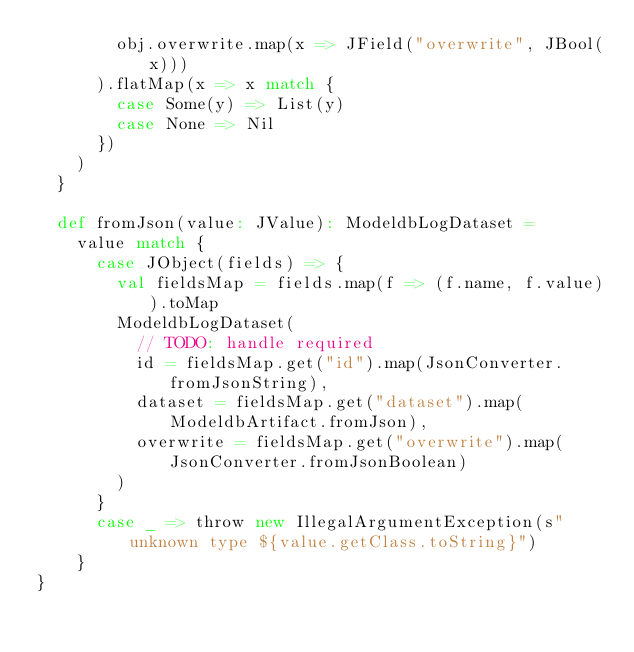Convert code to text. <code><loc_0><loc_0><loc_500><loc_500><_Scala_>        obj.overwrite.map(x => JField("overwrite", JBool(x)))
      ).flatMap(x => x match {
        case Some(y) => List(y)
        case None => Nil
      })
    )
  }

  def fromJson(value: JValue): ModeldbLogDataset =
    value match {
      case JObject(fields) => {
        val fieldsMap = fields.map(f => (f.name, f.value)).toMap
        ModeldbLogDataset(
          // TODO: handle required
          id = fieldsMap.get("id").map(JsonConverter.fromJsonString),
          dataset = fieldsMap.get("dataset").map(ModeldbArtifact.fromJson),
          overwrite = fieldsMap.get("overwrite").map(JsonConverter.fromJsonBoolean)
        )
      }
      case _ => throw new IllegalArgumentException(s"unknown type ${value.getClass.toString}")
    }
}
</code> 